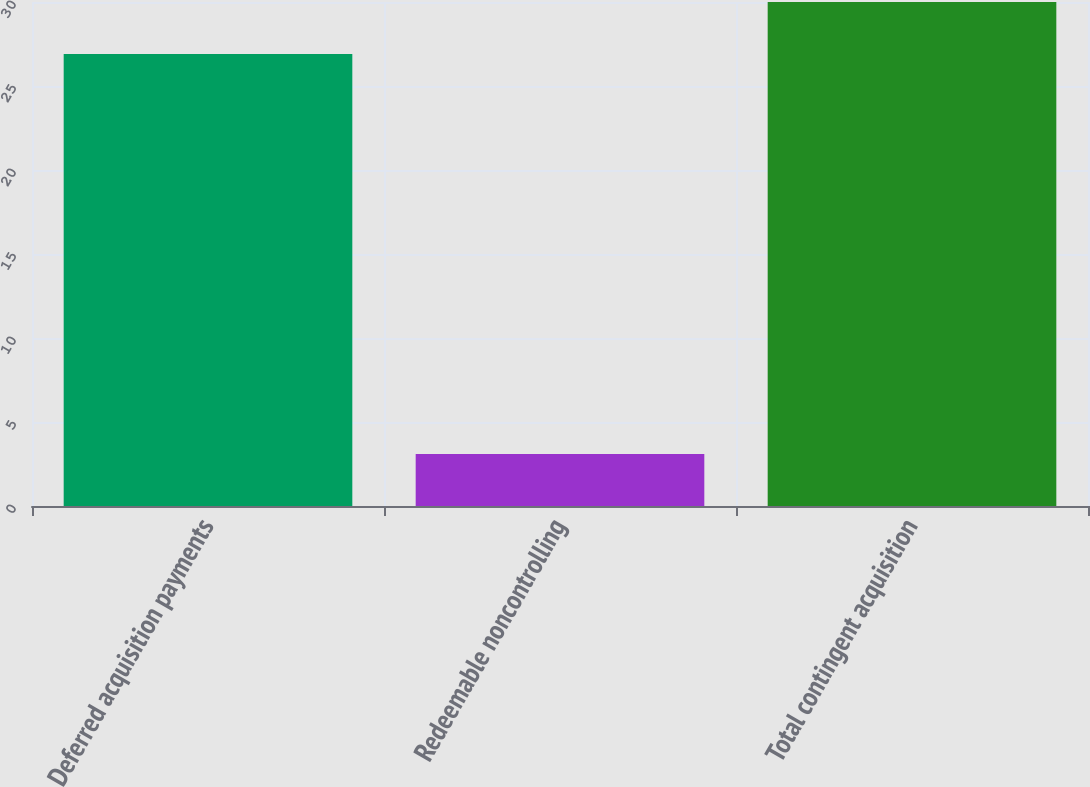Convert chart. <chart><loc_0><loc_0><loc_500><loc_500><bar_chart><fcel>Deferred acquisition payments<fcel>Redeemable noncontrolling<fcel>Total contingent acquisition<nl><fcel>26.9<fcel>3.1<fcel>30<nl></chart> 